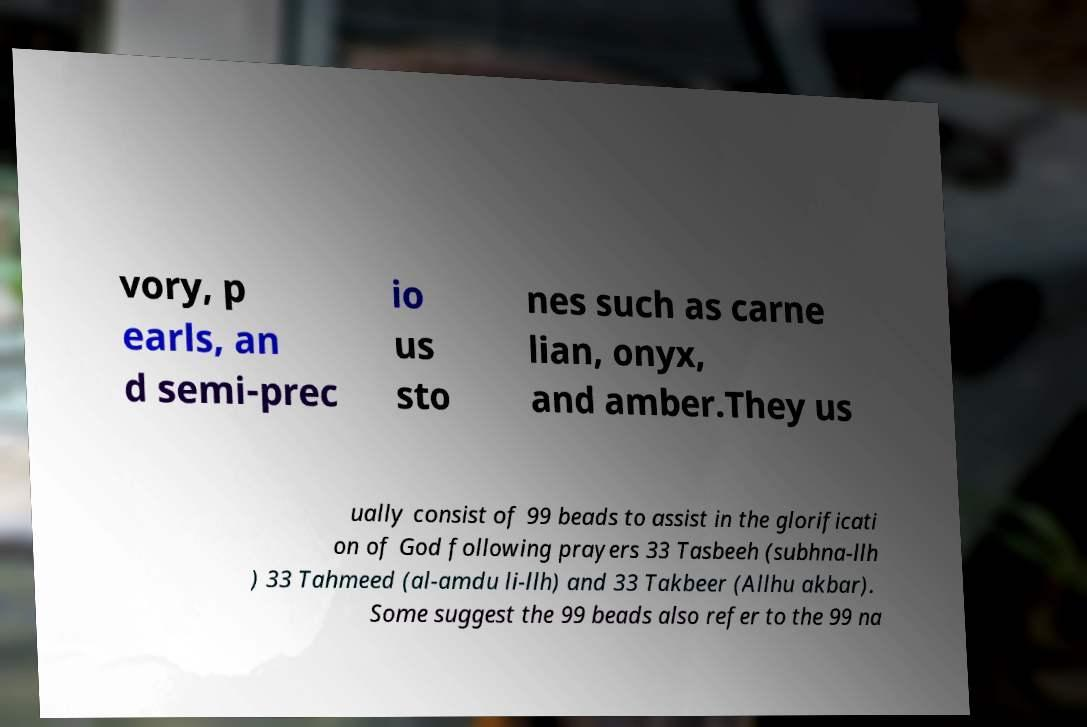Please read and relay the text visible in this image. What does it say? vory, p earls, an d semi-prec io us sto nes such as carne lian, onyx, and amber.They us ually consist of 99 beads to assist in the glorificati on of God following prayers 33 Tasbeeh (subhna-llh ) 33 Tahmeed (al-amdu li-llh) and 33 Takbeer (Allhu akbar). Some suggest the 99 beads also refer to the 99 na 